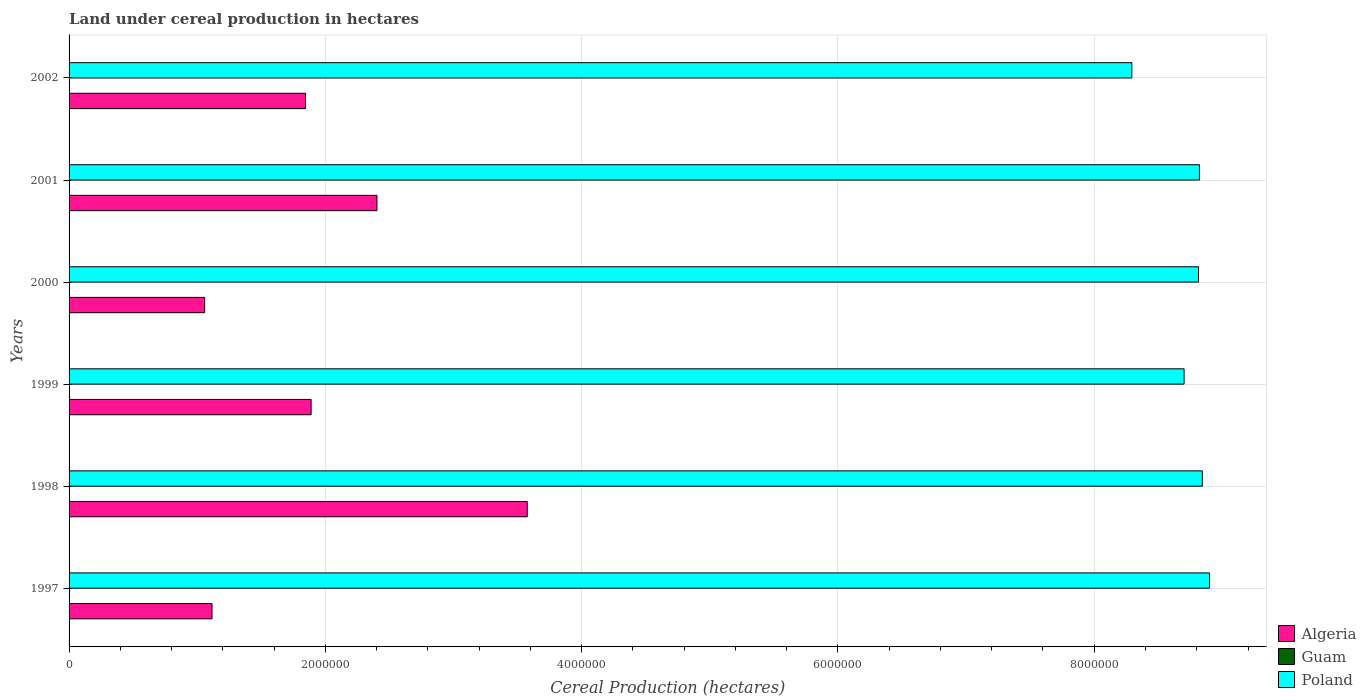How many different coloured bars are there?
Your answer should be very brief. 3. How many groups of bars are there?
Ensure brevity in your answer.  6. Are the number of bars per tick equal to the number of legend labels?
Provide a short and direct response. Yes. Are the number of bars on each tick of the Y-axis equal?
Give a very brief answer. Yes. How many bars are there on the 4th tick from the top?
Your answer should be compact. 3. In how many cases, is the number of bars for a given year not equal to the number of legend labels?
Your response must be concise. 0. What is the land under cereal production in Poland in 2002?
Your answer should be very brief. 8.29e+06. Across all years, what is the maximum land under cereal production in Guam?
Give a very brief answer. 16. Across all years, what is the minimum land under cereal production in Algeria?
Keep it short and to the point. 1.06e+06. In which year was the land under cereal production in Poland minimum?
Your response must be concise. 2002. What is the total land under cereal production in Poland in the graph?
Make the answer very short. 5.24e+07. What is the difference between the land under cereal production in Guam in 1998 and that in 1999?
Your answer should be very brief. -2. What is the difference between the land under cereal production in Algeria in 2001 and the land under cereal production in Guam in 2002?
Keep it short and to the point. 2.40e+06. What is the average land under cereal production in Poland per year?
Your answer should be very brief. 8.73e+06. In the year 1999, what is the difference between the land under cereal production in Guam and land under cereal production in Algeria?
Your response must be concise. -1.89e+06. In how many years, is the land under cereal production in Guam greater than 400000 hectares?
Your answer should be very brief. 0. What is the ratio of the land under cereal production in Algeria in 1997 to that in 2000?
Your answer should be very brief. 1.05. What is the difference between the highest and the second highest land under cereal production in Guam?
Your response must be concise. 1. What is the difference between the highest and the lowest land under cereal production in Guam?
Provide a succinct answer. 4. Is the sum of the land under cereal production in Poland in 1999 and 2001 greater than the maximum land under cereal production in Guam across all years?
Give a very brief answer. Yes. What does the 1st bar from the top in 2001 represents?
Provide a short and direct response. Poland. How many years are there in the graph?
Make the answer very short. 6. What is the difference between two consecutive major ticks on the X-axis?
Provide a short and direct response. 2.00e+06. Are the values on the major ticks of X-axis written in scientific E-notation?
Give a very brief answer. No. How many legend labels are there?
Make the answer very short. 3. What is the title of the graph?
Provide a short and direct response. Land under cereal production in hectares. Does "Slovenia" appear as one of the legend labels in the graph?
Give a very brief answer. No. What is the label or title of the X-axis?
Your answer should be compact. Cereal Production (hectares). What is the label or title of the Y-axis?
Give a very brief answer. Years. What is the Cereal Production (hectares) of Algeria in 1997?
Offer a very short reply. 1.12e+06. What is the Cereal Production (hectares) in Guam in 1997?
Your answer should be compact. 14. What is the Cereal Production (hectares) in Poland in 1997?
Offer a terse response. 8.90e+06. What is the Cereal Production (hectares) of Algeria in 1998?
Your answer should be compact. 3.58e+06. What is the Cereal Production (hectares) of Poland in 1998?
Give a very brief answer. 8.84e+06. What is the Cereal Production (hectares) of Algeria in 1999?
Keep it short and to the point. 1.89e+06. What is the Cereal Production (hectares) in Guam in 1999?
Give a very brief answer. 14. What is the Cereal Production (hectares) in Poland in 1999?
Ensure brevity in your answer.  8.70e+06. What is the Cereal Production (hectares) in Algeria in 2000?
Offer a terse response. 1.06e+06. What is the Cereal Production (hectares) of Poland in 2000?
Your answer should be compact. 8.81e+06. What is the Cereal Production (hectares) in Algeria in 2001?
Offer a terse response. 2.40e+06. What is the Cereal Production (hectares) of Guam in 2001?
Your answer should be compact. 14. What is the Cereal Production (hectares) in Poland in 2001?
Provide a succinct answer. 8.82e+06. What is the Cereal Production (hectares) of Algeria in 2002?
Your response must be concise. 1.85e+06. What is the Cereal Production (hectares) in Guam in 2002?
Your answer should be compact. 15. What is the Cereal Production (hectares) of Poland in 2002?
Offer a very short reply. 8.29e+06. Across all years, what is the maximum Cereal Production (hectares) in Algeria?
Make the answer very short. 3.58e+06. Across all years, what is the maximum Cereal Production (hectares) in Poland?
Offer a terse response. 8.90e+06. Across all years, what is the minimum Cereal Production (hectares) in Algeria?
Offer a terse response. 1.06e+06. Across all years, what is the minimum Cereal Production (hectares) of Poland?
Ensure brevity in your answer.  8.29e+06. What is the total Cereal Production (hectares) of Algeria in the graph?
Give a very brief answer. 1.19e+07. What is the total Cereal Production (hectares) of Poland in the graph?
Give a very brief answer. 5.24e+07. What is the difference between the Cereal Production (hectares) of Algeria in 1997 and that in 1998?
Provide a succinct answer. -2.46e+06. What is the difference between the Cereal Production (hectares) of Guam in 1997 and that in 1998?
Provide a succinct answer. 2. What is the difference between the Cereal Production (hectares) of Poland in 1997 and that in 1998?
Provide a succinct answer. 5.57e+04. What is the difference between the Cereal Production (hectares) in Algeria in 1997 and that in 1999?
Offer a terse response. -7.73e+05. What is the difference between the Cereal Production (hectares) of Poland in 1997 and that in 1999?
Your answer should be very brief. 1.98e+05. What is the difference between the Cereal Production (hectares) in Algeria in 1997 and that in 2000?
Offer a very short reply. 5.76e+04. What is the difference between the Cereal Production (hectares) of Guam in 1997 and that in 2000?
Provide a succinct answer. -2. What is the difference between the Cereal Production (hectares) of Poland in 1997 and that in 2000?
Your answer should be very brief. 8.58e+04. What is the difference between the Cereal Production (hectares) in Algeria in 1997 and that in 2001?
Your response must be concise. -1.29e+06. What is the difference between the Cereal Production (hectares) of Poland in 1997 and that in 2001?
Provide a short and direct response. 7.85e+04. What is the difference between the Cereal Production (hectares) in Algeria in 1997 and that in 2002?
Provide a short and direct response. -7.29e+05. What is the difference between the Cereal Production (hectares) of Guam in 1997 and that in 2002?
Ensure brevity in your answer.  -1. What is the difference between the Cereal Production (hectares) of Poland in 1997 and that in 2002?
Your response must be concise. 6.06e+05. What is the difference between the Cereal Production (hectares) of Algeria in 1998 and that in 1999?
Make the answer very short. 1.69e+06. What is the difference between the Cereal Production (hectares) in Poland in 1998 and that in 1999?
Ensure brevity in your answer.  1.42e+05. What is the difference between the Cereal Production (hectares) in Algeria in 1998 and that in 2000?
Your answer should be compact. 2.52e+06. What is the difference between the Cereal Production (hectares) in Guam in 1998 and that in 2000?
Offer a terse response. -4. What is the difference between the Cereal Production (hectares) of Poland in 1998 and that in 2000?
Keep it short and to the point. 3.01e+04. What is the difference between the Cereal Production (hectares) in Algeria in 1998 and that in 2001?
Make the answer very short. 1.17e+06. What is the difference between the Cereal Production (hectares) in Guam in 1998 and that in 2001?
Provide a short and direct response. -2. What is the difference between the Cereal Production (hectares) of Poland in 1998 and that in 2001?
Your response must be concise. 2.28e+04. What is the difference between the Cereal Production (hectares) in Algeria in 1998 and that in 2002?
Offer a very short reply. 1.73e+06. What is the difference between the Cereal Production (hectares) of Guam in 1998 and that in 2002?
Ensure brevity in your answer.  -3. What is the difference between the Cereal Production (hectares) in Poland in 1998 and that in 2002?
Ensure brevity in your answer.  5.50e+05. What is the difference between the Cereal Production (hectares) in Algeria in 1999 and that in 2000?
Offer a terse response. 8.31e+05. What is the difference between the Cereal Production (hectares) in Poland in 1999 and that in 2000?
Keep it short and to the point. -1.12e+05. What is the difference between the Cereal Production (hectares) of Algeria in 1999 and that in 2001?
Your answer should be very brief. -5.14e+05. What is the difference between the Cereal Production (hectares) of Poland in 1999 and that in 2001?
Offer a terse response. -1.20e+05. What is the difference between the Cereal Production (hectares) in Algeria in 1999 and that in 2002?
Ensure brevity in your answer.  4.37e+04. What is the difference between the Cereal Production (hectares) in Guam in 1999 and that in 2002?
Your answer should be very brief. -1. What is the difference between the Cereal Production (hectares) of Poland in 1999 and that in 2002?
Make the answer very short. 4.08e+05. What is the difference between the Cereal Production (hectares) in Algeria in 2000 and that in 2001?
Provide a succinct answer. -1.34e+06. What is the difference between the Cereal Production (hectares) in Poland in 2000 and that in 2001?
Offer a very short reply. -7312. What is the difference between the Cereal Production (hectares) in Algeria in 2000 and that in 2002?
Make the answer very short. -7.87e+05. What is the difference between the Cereal Production (hectares) of Guam in 2000 and that in 2002?
Your answer should be very brief. 1. What is the difference between the Cereal Production (hectares) in Poland in 2000 and that in 2002?
Make the answer very short. 5.20e+05. What is the difference between the Cereal Production (hectares) in Algeria in 2001 and that in 2002?
Your answer should be compact. 5.57e+05. What is the difference between the Cereal Production (hectares) of Poland in 2001 and that in 2002?
Provide a short and direct response. 5.28e+05. What is the difference between the Cereal Production (hectares) of Algeria in 1997 and the Cereal Production (hectares) of Guam in 1998?
Your response must be concise. 1.12e+06. What is the difference between the Cereal Production (hectares) of Algeria in 1997 and the Cereal Production (hectares) of Poland in 1998?
Provide a short and direct response. -7.73e+06. What is the difference between the Cereal Production (hectares) in Guam in 1997 and the Cereal Production (hectares) in Poland in 1998?
Ensure brevity in your answer.  -8.84e+06. What is the difference between the Cereal Production (hectares) in Algeria in 1997 and the Cereal Production (hectares) in Guam in 1999?
Make the answer very short. 1.12e+06. What is the difference between the Cereal Production (hectares) of Algeria in 1997 and the Cereal Production (hectares) of Poland in 1999?
Ensure brevity in your answer.  -7.59e+06. What is the difference between the Cereal Production (hectares) in Guam in 1997 and the Cereal Production (hectares) in Poland in 1999?
Your answer should be very brief. -8.70e+06. What is the difference between the Cereal Production (hectares) of Algeria in 1997 and the Cereal Production (hectares) of Guam in 2000?
Your response must be concise. 1.12e+06. What is the difference between the Cereal Production (hectares) of Algeria in 1997 and the Cereal Production (hectares) of Poland in 2000?
Your answer should be very brief. -7.70e+06. What is the difference between the Cereal Production (hectares) in Guam in 1997 and the Cereal Production (hectares) in Poland in 2000?
Make the answer very short. -8.81e+06. What is the difference between the Cereal Production (hectares) of Algeria in 1997 and the Cereal Production (hectares) of Guam in 2001?
Make the answer very short. 1.12e+06. What is the difference between the Cereal Production (hectares) of Algeria in 1997 and the Cereal Production (hectares) of Poland in 2001?
Provide a short and direct response. -7.71e+06. What is the difference between the Cereal Production (hectares) of Guam in 1997 and the Cereal Production (hectares) of Poland in 2001?
Your answer should be very brief. -8.82e+06. What is the difference between the Cereal Production (hectares) in Algeria in 1997 and the Cereal Production (hectares) in Guam in 2002?
Offer a very short reply. 1.12e+06. What is the difference between the Cereal Production (hectares) in Algeria in 1997 and the Cereal Production (hectares) in Poland in 2002?
Your response must be concise. -7.18e+06. What is the difference between the Cereal Production (hectares) of Guam in 1997 and the Cereal Production (hectares) of Poland in 2002?
Provide a short and direct response. -8.29e+06. What is the difference between the Cereal Production (hectares) of Algeria in 1998 and the Cereal Production (hectares) of Guam in 1999?
Offer a terse response. 3.58e+06. What is the difference between the Cereal Production (hectares) of Algeria in 1998 and the Cereal Production (hectares) of Poland in 1999?
Offer a terse response. -5.13e+06. What is the difference between the Cereal Production (hectares) in Guam in 1998 and the Cereal Production (hectares) in Poland in 1999?
Your answer should be compact. -8.70e+06. What is the difference between the Cereal Production (hectares) in Algeria in 1998 and the Cereal Production (hectares) in Guam in 2000?
Give a very brief answer. 3.58e+06. What is the difference between the Cereal Production (hectares) in Algeria in 1998 and the Cereal Production (hectares) in Poland in 2000?
Give a very brief answer. -5.24e+06. What is the difference between the Cereal Production (hectares) in Guam in 1998 and the Cereal Production (hectares) in Poland in 2000?
Make the answer very short. -8.81e+06. What is the difference between the Cereal Production (hectares) in Algeria in 1998 and the Cereal Production (hectares) in Guam in 2001?
Keep it short and to the point. 3.58e+06. What is the difference between the Cereal Production (hectares) in Algeria in 1998 and the Cereal Production (hectares) in Poland in 2001?
Offer a very short reply. -5.25e+06. What is the difference between the Cereal Production (hectares) of Guam in 1998 and the Cereal Production (hectares) of Poland in 2001?
Offer a very short reply. -8.82e+06. What is the difference between the Cereal Production (hectares) in Algeria in 1998 and the Cereal Production (hectares) in Guam in 2002?
Provide a succinct answer. 3.58e+06. What is the difference between the Cereal Production (hectares) of Algeria in 1998 and the Cereal Production (hectares) of Poland in 2002?
Give a very brief answer. -4.72e+06. What is the difference between the Cereal Production (hectares) of Guam in 1998 and the Cereal Production (hectares) of Poland in 2002?
Keep it short and to the point. -8.29e+06. What is the difference between the Cereal Production (hectares) in Algeria in 1999 and the Cereal Production (hectares) in Guam in 2000?
Ensure brevity in your answer.  1.89e+06. What is the difference between the Cereal Production (hectares) in Algeria in 1999 and the Cereal Production (hectares) in Poland in 2000?
Keep it short and to the point. -6.92e+06. What is the difference between the Cereal Production (hectares) of Guam in 1999 and the Cereal Production (hectares) of Poland in 2000?
Keep it short and to the point. -8.81e+06. What is the difference between the Cereal Production (hectares) of Algeria in 1999 and the Cereal Production (hectares) of Guam in 2001?
Ensure brevity in your answer.  1.89e+06. What is the difference between the Cereal Production (hectares) in Algeria in 1999 and the Cereal Production (hectares) in Poland in 2001?
Provide a short and direct response. -6.93e+06. What is the difference between the Cereal Production (hectares) of Guam in 1999 and the Cereal Production (hectares) of Poland in 2001?
Ensure brevity in your answer.  -8.82e+06. What is the difference between the Cereal Production (hectares) in Algeria in 1999 and the Cereal Production (hectares) in Guam in 2002?
Offer a terse response. 1.89e+06. What is the difference between the Cereal Production (hectares) in Algeria in 1999 and the Cereal Production (hectares) in Poland in 2002?
Keep it short and to the point. -6.40e+06. What is the difference between the Cereal Production (hectares) in Guam in 1999 and the Cereal Production (hectares) in Poland in 2002?
Ensure brevity in your answer.  -8.29e+06. What is the difference between the Cereal Production (hectares) of Algeria in 2000 and the Cereal Production (hectares) of Guam in 2001?
Your answer should be very brief. 1.06e+06. What is the difference between the Cereal Production (hectares) in Algeria in 2000 and the Cereal Production (hectares) in Poland in 2001?
Make the answer very short. -7.76e+06. What is the difference between the Cereal Production (hectares) of Guam in 2000 and the Cereal Production (hectares) of Poland in 2001?
Offer a very short reply. -8.82e+06. What is the difference between the Cereal Production (hectares) of Algeria in 2000 and the Cereal Production (hectares) of Guam in 2002?
Provide a short and direct response. 1.06e+06. What is the difference between the Cereal Production (hectares) of Algeria in 2000 and the Cereal Production (hectares) of Poland in 2002?
Give a very brief answer. -7.24e+06. What is the difference between the Cereal Production (hectares) of Guam in 2000 and the Cereal Production (hectares) of Poland in 2002?
Keep it short and to the point. -8.29e+06. What is the difference between the Cereal Production (hectares) in Algeria in 2001 and the Cereal Production (hectares) in Guam in 2002?
Ensure brevity in your answer.  2.40e+06. What is the difference between the Cereal Production (hectares) of Algeria in 2001 and the Cereal Production (hectares) of Poland in 2002?
Ensure brevity in your answer.  -5.89e+06. What is the difference between the Cereal Production (hectares) of Guam in 2001 and the Cereal Production (hectares) of Poland in 2002?
Provide a short and direct response. -8.29e+06. What is the average Cereal Production (hectares) in Algeria per year?
Offer a very short reply. 1.98e+06. What is the average Cereal Production (hectares) of Guam per year?
Keep it short and to the point. 14.17. What is the average Cereal Production (hectares) of Poland per year?
Give a very brief answer. 8.73e+06. In the year 1997, what is the difference between the Cereal Production (hectares) in Algeria and Cereal Production (hectares) in Guam?
Your response must be concise. 1.12e+06. In the year 1997, what is the difference between the Cereal Production (hectares) of Algeria and Cereal Production (hectares) of Poland?
Provide a succinct answer. -7.78e+06. In the year 1997, what is the difference between the Cereal Production (hectares) of Guam and Cereal Production (hectares) of Poland?
Provide a short and direct response. -8.90e+06. In the year 1998, what is the difference between the Cereal Production (hectares) of Algeria and Cereal Production (hectares) of Guam?
Offer a terse response. 3.58e+06. In the year 1998, what is the difference between the Cereal Production (hectares) of Algeria and Cereal Production (hectares) of Poland?
Provide a short and direct response. -5.27e+06. In the year 1998, what is the difference between the Cereal Production (hectares) of Guam and Cereal Production (hectares) of Poland?
Keep it short and to the point. -8.84e+06. In the year 1999, what is the difference between the Cereal Production (hectares) of Algeria and Cereal Production (hectares) of Guam?
Offer a terse response. 1.89e+06. In the year 1999, what is the difference between the Cereal Production (hectares) in Algeria and Cereal Production (hectares) in Poland?
Your response must be concise. -6.81e+06. In the year 1999, what is the difference between the Cereal Production (hectares) of Guam and Cereal Production (hectares) of Poland?
Provide a short and direct response. -8.70e+06. In the year 2000, what is the difference between the Cereal Production (hectares) of Algeria and Cereal Production (hectares) of Guam?
Give a very brief answer. 1.06e+06. In the year 2000, what is the difference between the Cereal Production (hectares) in Algeria and Cereal Production (hectares) in Poland?
Ensure brevity in your answer.  -7.76e+06. In the year 2000, what is the difference between the Cereal Production (hectares) of Guam and Cereal Production (hectares) of Poland?
Offer a terse response. -8.81e+06. In the year 2001, what is the difference between the Cereal Production (hectares) in Algeria and Cereal Production (hectares) in Guam?
Your answer should be compact. 2.40e+06. In the year 2001, what is the difference between the Cereal Production (hectares) in Algeria and Cereal Production (hectares) in Poland?
Keep it short and to the point. -6.42e+06. In the year 2001, what is the difference between the Cereal Production (hectares) of Guam and Cereal Production (hectares) of Poland?
Make the answer very short. -8.82e+06. In the year 2002, what is the difference between the Cereal Production (hectares) in Algeria and Cereal Production (hectares) in Guam?
Ensure brevity in your answer.  1.85e+06. In the year 2002, what is the difference between the Cereal Production (hectares) of Algeria and Cereal Production (hectares) of Poland?
Your response must be concise. -6.45e+06. In the year 2002, what is the difference between the Cereal Production (hectares) in Guam and Cereal Production (hectares) in Poland?
Offer a very short reply. -8.29e+06. What is the ratio of the Cereal Production (hectares) in Algeria in 1997 to that in 1998?
Your answer should be very brief. 0.31. What is the ratio of the Cereal Production (hectares) in Guam in 1997 to that in 1998?
Your response must be concise. 1.17. What is the ratio of the Cereal Production (hectares) of Poland in 1997 to that in 1998?
Your response must be concise. 1.01. What is the ratio of the Cereal Production (hectares) of Algeria in 1997 to that in 1999?
Your answer should be very brief. 0.59. What is the ratio of the Cereal Production (hectares) in Poland in 1997 to that in 1999?
Ensure brevity in your answer.  1.02. What is the ratio of the Cereal Production (hectares) in Algeria in 1997 to that in 2000?
Provide a short and direct response. 1.05. What is the ratio of the Cereal Production (hectares) of Guam in 1997 to that in 2000?
Provide a succinct answer. 0.88. What is the ratio of the Cereal Production (hectares) of Poland in 1997 to that in 2000?
Your answer should be compact. 1.01. What is the ratio of the Cereal Production (hectares) of Algeria in 1997 to that in 2001?
Your answer should be compact. 0.46. What is the ratio of the Cereal Production (hectares) of Guam in 1997 to that in 2001?
Your answer should be very brief. 1. What is the ratio of the Cereal Production (hectares) of Poland in 1997 to that in 2001?
Your response must be concise. 1.01. What is the ratio of the Cereal Production (hectares) in Algeria in 1997 to that in 2002?
Your answer should be very brief. 0.6. What is the ratio of the Cereal Production (hectares) in Guam in 1997 to that in 2002?
Your response must be concise. 0.93. What is the ratio of the Cereal Production (hectares) of Poland in 1997 to that in 2002?
Your answer should be compact. 1.07. What is the ratio of the Cereal Production (hectares) in Algeria in 1998 to that in 1999?
Offer a very short reply. 1.89. What is the ratio of the Cereal Production (hectares) in Guam in 1998 to that in 1999?
Provide a short and direct response. 0.86. What is the ratio of the Cereal Production (hectares) in Poland in 1998 to that in 1999?
Offer a very short reply. 1.02. What is the ratio of the Cereal Production (hectares) of Algeria in 1998 to that in 2000?
Make the answer very short. 3.38. What is the ratio of the Cereal Production (hectares) in Guam in 1998 to that in 2000?
Your answer should be very brief. 0.75. What is the ratio of the Cereal Production (hectares) of Algeria in 1998 to that in 2001?
Your answer should be compact. 1.49. What is the ratio of the Cereal Production (hectares) of Guam in 1998 to that in 2001?
Your answer should be very brief. 0.86. What is the ratio of the Cereal Production (hectares) in Poland in 1998 to that in 2001?
Your response must be concise. 1. What is the ratio of the Cereal Production (hectares) of Algeria in 1998 to that in 2002?
Give a very brief answer. 1.94. What is the ratio of the Cereal Production (hectares) of Poland in 1998 to that in 2002?
Ensure brevity in your answer.  1.07. What is the ratio of the Cereal Production (hectares) of Algeria in 1999 to that in 2000?
Your response must be concise. 1.79. What is the ratio of the Cereal Production (hectares) in Guam in 1999 to that in 2000?
Offer a very short reply. 0.88. What is the ratio of the Cereal Production (hectares) of Poland in 1999 to that in 2000?
Give a very brief answer. 0.99. What is the ratio of the Cereal Production (hectares) in Algeria in 1999 to that in 2001?
Your response must be concise. 0.79. What is the ratio of the Cereal Production (hectares) of Guam in 1999 to that in 2001?
Your answer should be very brief. 1. What is the ratio of the Cereal Production (hectares) in Poland in 1999 to that in 2001?
Give a very brief answer. 0.99. What is the ratio of the Cereal Production (hectares) of Algeria in 1999 to that in 2002?
Keep it short and to the point. 1.02. What is the ratio of the Cereal Production (hectares) in Guam in 1999 to that in 2002?
Ensure brevity in your answer.  0.93. What is the ratio of the Cereal Production (hectares) of Poland in 1999 to that in 2002?
Offer a very short reply. 1.05. What is the ratio of the Cereal Production (hectares) of Algeria in 2000 to that in 2001?
Your response must be concise. 0.44. What is the ratio of the Cereal Production (hectares) in Guam in 2000 to that in 2001?
Ensure brevity in your answer.  1.14. What is the ratio of the Cereal Production (hectares) in Algeria in 2000 to that in 2002?
Offer a very short reply. 0.57. What is the ratio of the Cereal Production (hectares) of Guam in 2000 to that in 2002?
Make the answer very short. 1.07. What is the ratio of the Cereal Production (hectares) in Poland in 2000 to that in 2002?
Ensure brevity in your answer.  1.06. What is the ratio of the Cereal Production (hectares) in Algeria in 2001 to that in 2002?
Keep it short and to the point. 1.3. What is the ratio of the Cereal Production (hectares) in Poland in 2001 to that in 2002?
Offer a very short reply. 1.06. What is the difference between the highest and the second highest Cereal Production (hectares) in Algeria?
Offer a terse response. 1.17e+06. What is the difference between the highest and the second highest Cereal Production (hectares) in Poland?
Offer a very short reply. 5.57e+04. What is the difference between the highest and the lowest Cereal Production (hectares) in Algeria?
Your answer should be very brief. 2.52e+06. What is the difference between the highest and the lowest Cereal Production (hectares) of Guam?
Keep it short and to the point. 4. What is the difference between the highest and the lowest Cereal Production (hectares) in Poland?
Your answer should be compact. 6.06e+05. 